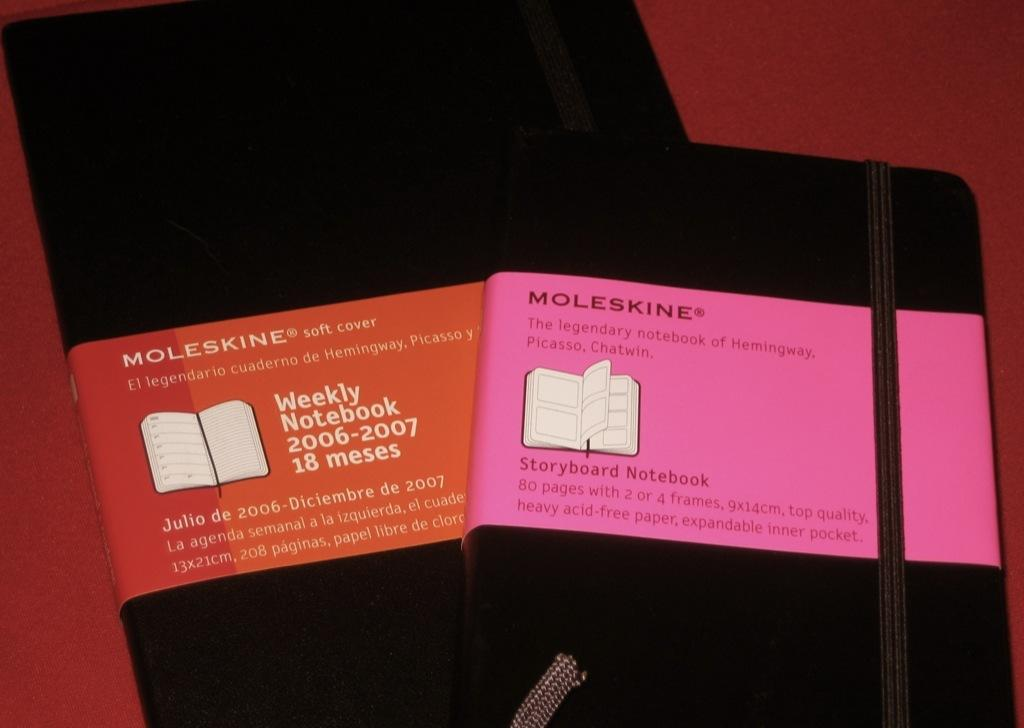What are the two black objects in the image? There are two black objects in the image, but their specific nature is not mentioned in the facts. How can the objects be identified? The black objects have labels, which may provide information about their identity. What is the color of the surface on which the objects are placed? The objects are on a red surface. Is the girl in the middle of the image? There is no mention of a girl or any person in the image, so it cannot be determined if there is a girl or if she is in the middle of the image. 